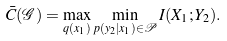<formula> <loc_0><loc_0><loc_500><loc_500>\bar { C } ( \mathcal { G } ) = \max _ { q ( x _ { 1 } ) } \min _ { p ( y _ { 2 } | x _ { 1 } ) \in \mathcal { P } } I ( X _ { 1 } ; Y _ { 2 } ) .</formula> 